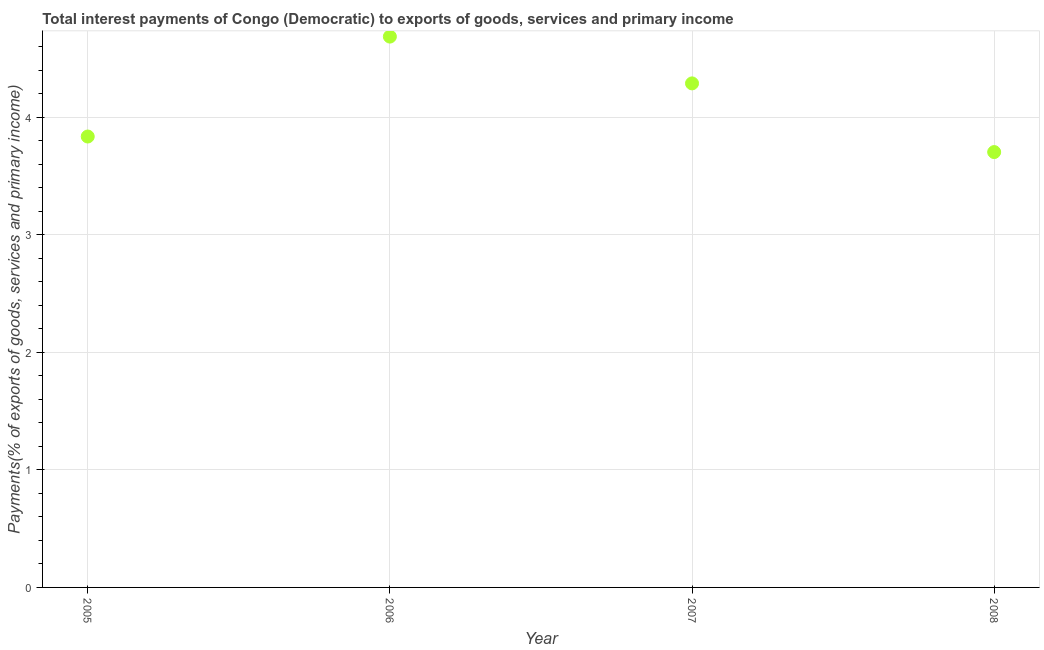What is the total interest payments on external debt in 2005?
Your answer should be compact. 3.84. Across all years, what is the maximum total interest payments on external debt?
Ensure brevity in your answer.  4.69. Across all years, what is the minimum total interest payments on external debt?
Ensure brevity in your answer.  3.71. What is the sum of the total interest payments on external debt?
Your answer should be compact. 16.52. What is the difference between the total interest payments on external debt in 2007 and 2008?
Ensure brevity in your answer.  0.58. What is the average total interest payments on external debt per year?
Keep it short and to the point. 4.13. What is the median total interest payments on external debt?
Your response must be concise. 4.06. In how many years, is the total interest payments on external debt greater than 3.2 %?
Make the answer very short. 4. What is the ratio of the total interest payments on external debt in 2006 to that in 2008?
Offer a terse response. 1.27. Is the total interest payments on external debt in 2006 less than that in 2008?
Your answer should be compact. No. What is the difference between the highest and the second highest total interest payments on external debt?
Offer a terse response. 0.4. Is the sum of the total interest payments on external debt in 2007 and 2008 greater than the maximum total interest payments on external debt across all years?
Provide a short and direct response. Yes. What is the difference between the highest and the lowest total interest payments on external debt?
Keep it short and to the point. 0.98. In how many years, is the total interest payments on external debt greater than the average total interest payments on external debt taken over all years?
Provide a short and direct response. 2. How many dotlines are there?
Provide a short and direct response. 1. How many years are there in the graph?
Your response must be concise. 4. Are the values on the major ticks of Y-axis written in scientific E-notation?
Provide a succinct answer. No. Does the graph contain grids?
Ensure brevity in your answer.  Yes. What is the title of the graph?
Offer a very short reply. Total interest payments of Congo (Democratic) to exports of goods, services and primary income. What is the label or title of the Y-axis?
Offer a very short reply. Payments(% of exports of goods, services and primary income). What is the Payments(% of exports of goods, services and primary income) in 2005?
Provide a succinct answer. 3.84. What is the Payments(% of exports of goods, services and primary income) in 2006?
Give a very brief answer. 4.69. What is the Payments(% of exports of goods, services and primary income) in 2007?
Provide a short and direct response. 4.29. What is the Payments(% of exports of goods, services and primary income) in 2008?
Offer a terse response. 3.71. What is the difference between the Payments(% of exports of goods, services and primary income) in 2005 and 2006?
Offer a very short reply. -0.85. What is the difference between the Payments(% of exports of goods, services and primary income) in 2005 and 2007?
Make the answer very short. -0.45. What is the difference between the Payments(% of exports of goods, services and primary income) in 2005 and 2008?
Give a very brief answer. 0.13. What is the difference between the Payments(% of exports of goods, services and primary income) in 2006 and 2007?
Provide a short and direct response. 0.4. What is the difference between the Payments(% of exports of goods, services and primary income) in 2006 and 2008?
Offer a terse response. 0.98. What is the difference between the Payments(% of exports of goods, services and primary income) in 2007 and 2008?
Ensure brevity in your answer.  0.58. What is the ratio of the Payments(% of exports of goods, services and primary income) in 2005 to that in 2006?
Your answer should be very brief. 0.82. What is the ratio of the Payments(% of exports of goods, services and primary income) in 2005 to that in 2007?
Offer a terse response. 0.9. What is the ratio of the Payments(% of exports of goods, services and primary income) in 2005 to that in 2008?
Provide a succinct answer. 1.04. What is the ratio of the Payments(% of exports of goods, services and primary income) in 2006 to that in 2007?
Make the answer very short. 1.09. What is the ratio of the Payments(% of exports of goods, services and primary income) in 2006 to that in 2008?
Offer a terse response. 1.26. What is the ratio of the Payments(% of exports of goods, services and primary income) in 2007 to that in 2008?
Offer a very short reply. 1.16. 